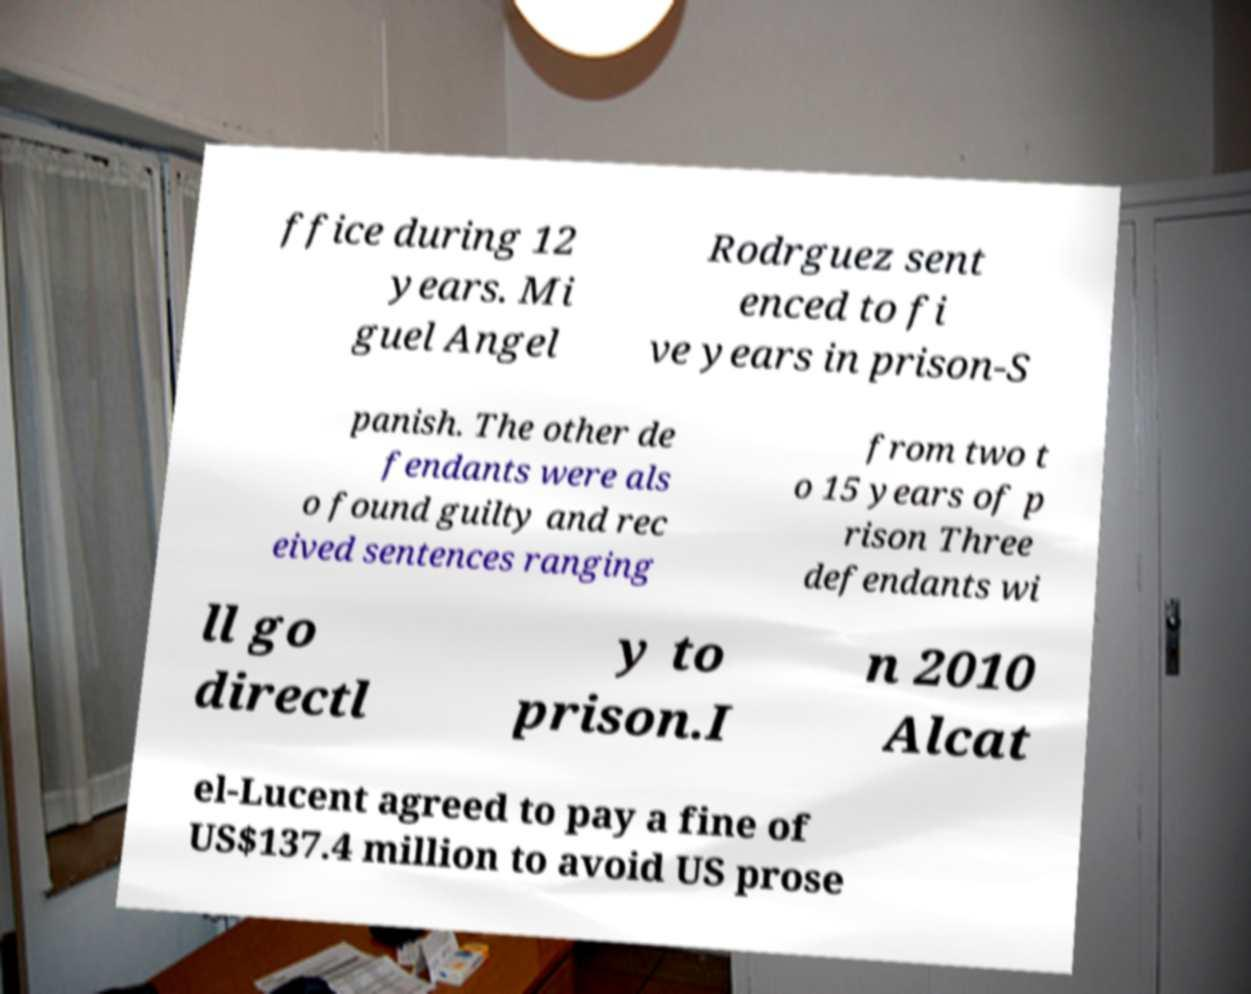For documentation purposes, I need the text within this image transcribed. Could you provide that? ffice during 12 years. Mi guel Angel Rodrguez sent enced to fi ve years in prison-S panish. The other de fendants were als o found guilty and rec eived sentences ranging from two t o 15 years of p rison Three defendants wi ll go directl y to prison.I n 2010 Alcat el-Lucent agreed to pay a fine of US$137.4 million to avoid US prose 